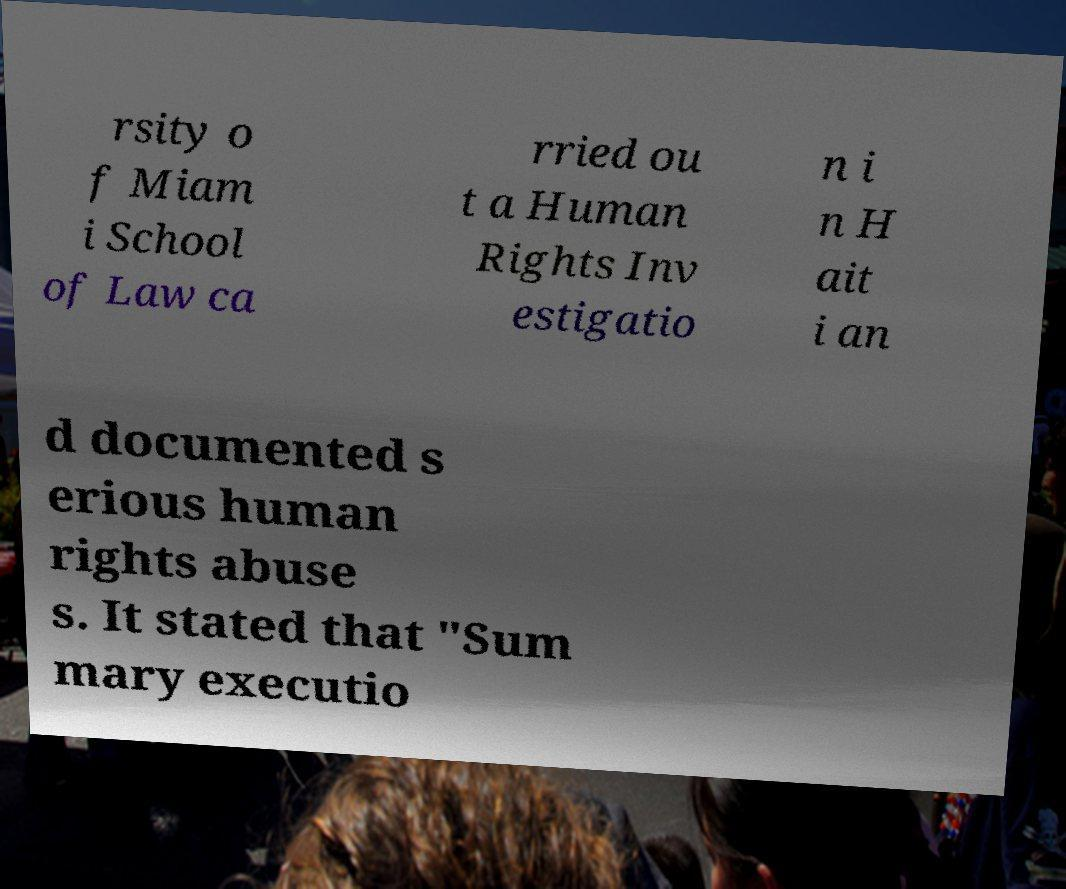Please read and relay the text visible in this image. What does it say? rsity o f Miam i School of Law ca rried ou t a Human Rights Inv estigatio n i n H ait i an d documented s erious human rights abuse s. It stated that "Sum mary executio 